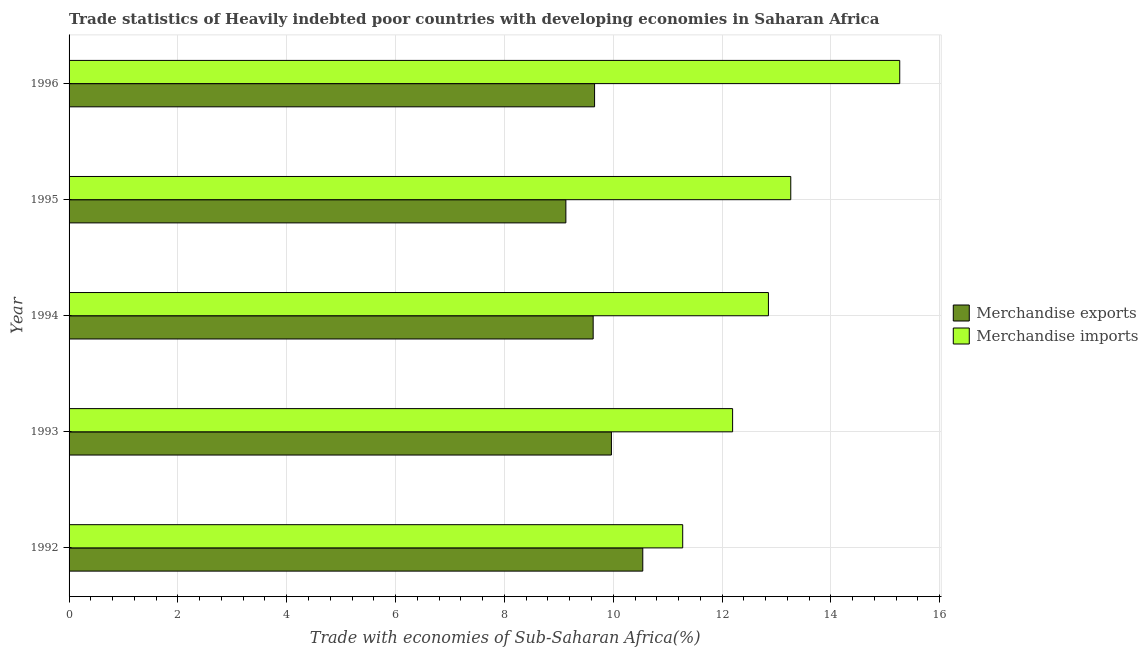How many different coloured bars are there?
Provide a short and direct response. 2. How many groups of bars are there?
Offer a very short reply. 5. Are the number of bars on each tick of the Y-axis equal?
Provide a short and direct response. Yes. How many bars are there on the 1st tick from the top?
Keep it short and to the point. 2. How many bars are there on the 1st tick from the bottom?
Offer a terse response. 2. What is the label of the 3rd group of bars from the top?
Your answer should be compact. 1994. In how many cases, is the number of bars for a given year not equal to the number of legend labels?
Provide a succinct answer. 0. What is the merchandise exports in 1993?
Make the answer very short. 9.97. Across all years, what is the maximum merchandise exports?
Offer a terse response. 10.54. Across all years, what is the minimum merchandise imports?
Keep it short and to the point. 11.28. In which year was the merchandise exports maximum?
Your response must be concise. 1992. What is the total merchandise exports in the graph?
Make the answer very short. 48.93. What is the difference between the merchandise exports in 1993 and that in 1995?
Provide a succinct answer. 0.84. What is the difference between the merchandise exports in 1994 and the merchandise imports in 1993?
Provide a succinct answer. -2.56. What is the average merchandise imports per year?
Make the answer very short. 12.97. In the year 1993, what is the difference between the merchandise imports and merchandise exports?
Give a very brief answer. 2.23. What is the ratio of the merchandise exports in 1994 to that in 1996?
Provide a short and direct response. 1. What is the difference between the highest and the second highest merchandise exports?
Your answer should be compact. 0.58. What is the difference between the highest and the lowest merchandise imports?
Provide a short and direct response. 3.99. Is the sum of the merchandise imports in 1992 and 1993 greater than the maximum merchandise exports across all years?
Make the answer very short. Yes. What does the 1st bar from the bottom in 1993 represents?
Keep it short and to the point. Merchandise exports. How many years are there in the graph?
Offer a terse response. 5. What is the difference between two consecutive major ticks on the X-axis?
Provide a short and direct response. 2. Does the graph contain grids?
Ensure brevity in your answer.  Yes. What is the title of the graph?
Offer a terse response. Trade statistics of Heavily indebted poor countries with developing economies in Saharan Africa. What is the label or title of the X-axis?
Your answer should be compact. Trade with economies of Sub-Saharan Africa(%). What is the label or title of the Y-axis?
Give a very brief answer. Year. What is the Trade with economies of Sub-Saharan Africa(%) of Merchandise exports in 1992?
Keep it short and to the point. 10.54. What is the Trade with economies of Sub-Saharan Africa(%) of Merchandise imports in 1992?
Keep it short and to the point. 11.28. What is the Trade with economies of Sub-Saharan Africa(%) in Merchandise exports in 1993?
Ensure brevity in your answer.  9.97. What is the Trade with economies of Sub-Saharan Africa(%) in Merchandise imports in 1993?
Keep it short and to the point. 12.19. What is the Trade with economies of Sub-Saharan Africa(%) in Merchandise exports in 1994?
Provide a short and direct response. 9.63. What is the Trade with economies of Sub-Saharan Africa(%) in Merchandise imports in 1994?
Your answer should be compact. 12.85. What is the Trade with economies of Sub-Saharan Africa(%) in Merchandise exports in 1995?
Your answer should be very brief. 9.13. What is the Trade with economies of Sub-Saharan Africa(%) of Merchandise imports in 1995?
Ensure brevity in your answer.  13.26. What is the Trade with economies of Sub-Saharan Africa(%) of Merchandise exports in 1996?
Ensure brevity in your answer.  9.66. What is the Trade with economies of Sub-Saharan Africa(%) in Merchandise imports in 1996?
Your answer should be very brief. 15.27. Across all years, what is the maximum Trade with economies of Sub-Saharan Africa(%) of Merchandise exports?
Offer a terse response. 10.54. Across all years, what is the maximum Trade with economies of Sub-Saharan Africa(%) of Merchandise imports?
Your response must be concise. 15.27. Across all years, what is the minimum Trade with economies of Sub-Saharan Africa(%) in Merchandise exports?
Provide a succinct answer. 9.13. Across all years, what is the minimum Trade with economies of Sub-Saharan Africa(%) of Merchandise imports?
Keep it short and to the point. 11.28. What is the total Trade with economies of Sub-Saharan Africa(%) in Merchandise exports in the graph?
Offer a very short reply. 48.93. What is the total Trade with economies of Sub-Saharan Africa(%) of Merchandise imports in the graph?
Give a very brief answer. 64.85. What is the difference between the Trade with economies of Sub-Saharan Africa(%) in Merchandise exports in 1992 and that in 1993?
Offer a very short reply. 0.58. What is the difference between the Trade with economies of Sub-Saharan Africa(%) in Merchandise imports in 1992 and that in 1993?
Offer a terse response. -0.92. What is the difference between the Trade with economies of Sub-Saharan Africa(%) of Merchandise exports in 1992 and that in 1994?
Offer a very short reply. 0.91. What is the difference between the Trade with economies of Sub-Saharan Africa(%) of Merchandise imports in 1992 and that in 1994?
Your answer should be compact. -1.58. What is the difference between the Trade with economies of Sub-Saharan Africa(%) in Merchandise exports in 1992 and that in 1995?
Make the answer very short. 1.41. What is the difference between the Trade with economies of Sub-Saharan Africa(%) in Merchandise imports in 1992 and that in 1995?
Your answer should be very brief. -1.99. What is the difference between the Trade with economies of Sub-Saharan Africa(%) of Merchandise exports in 1992 and that in 1996?
Your answer should be compact. 0.89. What is the difference between the Trade with economies of Sub-Saharan Africa(%) in Merchandise imports in 1992 and that in 1996?
Provide a short and direct response. -3.99. What is the difference between the Trade with economies of Sub-Saharan Africa(%) of Merchandise exports in 1993 and that in 1994?
Make the answer very short. 0.34. What is the difference between the Trade with economies of Sub-Saharan Africa(%) of Merchandise imports in 1993 and that in 1994?
Provide a succinct answer. -0.66. What is the difference between the Trade with economies of Sub-Saharan Africa(%) in Merchandise exports in 1993 and that in 1995?
Make the answer very short. 0.84. What is the difference between the Trade with economies of Sub-Saharan Africa(%) in Merchandise imports in 1993 and that in 1995?
Provide a short and direct response. -1.07. What is the difference between the Trade with economies of Sub-Saharan Africa(%) in Merchandise exports in 1993 and that in 1996?
Provide a succinct answer. 0.31. What is the difference between the Trade with economies of Sub-Saharan Africa(%) in Merchandise imports in 1993 and that in 1996?
Keep it short and to the point. -3.07. What is the difference between the Trade with economies of Sub-Saharan Africa(%) of Merchandise exports in 1994 and that in 1995?
Provide a succinct answer. 0.5. What is the difference between the Trade with economies of Sub-Saharan Africa(%) in Merchandise imports in 1994 and that in 1995?
Offer a terse response. -0.41. What is the difference between the Trade with economies of Sub-Saharan Africa(%) in Merchandise exports in 1994 and that in 1996?
Offer a terse response. -0.03. What is the difference between the Trade with economies of Sub-Saharan Africa(%) in Merchandise imports in 1994 and that in 1996?
Your answer should be very brief. -2.41. What is the difference between the Trade with economies of Sub-Saharan Africa(%) in Merchandise exports in 1995 and that in 1996?
Give a very brief answer. -0.53. What is the difference between the Trade with economies of Sub-Saharan Africa(%) of Merchandise imports in 1995 and that in 1996?
Your response must be concise. -2. What is the difference between the Trade with economies of Sub-Saharan Africa(%) in Merchandise exports in 1992 and the Trade with economies of Sub-Saharan Africa(%) in Merchandise imports in 1993?
Offer a very short reply. -1.65. What is the difference between the Trade with economies of Sub-Saharan Africa(%) in Merchandise exports in 1992 and the Trade with economies of Sub-Saharan Africa(%) in Merchandise imports in 1994?
Keep it short and to the point. -2.31. What is the difference between the Trade with economies of Sub-Saharan Africa(%) in Merchandise exports in 1992 and the Trade with economies of Sub-Saharan Africa(%) in Merchandise imports in 1995?
Your answer should be compact. -2.72. What is the difference between the Trade with economies of Sub-Saharan Africa(%) in Merchandise exports in 1992 and the Trade with economies of Sub-Saharan Africa(%) in Merchandise imports in 1996?
Your answer should be very brief. -4.72. What is the difference between the Trade with economies of Sub-Saharan Africa(%) in Merchandise exports in 1993 and the Trade with economies of Sub-Saharan Africa(%) in Merchandise imports in 1994?
Make the answer very short. -2.89. What is the difference between the Trade with economies of Sub-Saharan Africa(%) in Merchandise exports in 1993 and the Trade with economies of Sub-Saharan Africa(%) in Merchandise imports in 1995?
Your answer should be compact. -3.3. What is the difference between the Trade with economies of Sub-Saharan Africa(%) of Merchandise exports in 1993 and the Trade with economies of Sub-Saharan Africa(%) of Merchandise imports in 1996?
Your answer should be very brief. -5.3. What is the difference between the Trade with economies of Sub-Saharan Africa(%) of Merchandise exports in 1994 and the Trade with economies of Sub-Saharan Africa(%) of Merchandise imports in 1995?
Offer a very short reply. -3.63. What is the difference between the Trade with economies of Sub-Saharan Africa(%) in Merchandise exports in 1994 and the Trade with economies of Sub-Saharan Africa(%) in Merchandise imports in 1996?
Give a very brief answer. -5.63. What is the difference between the Trade with economies of Sub-Saharan Africa(%) of Merchandise exports in 1995 and the Trade with economies of Sub-Saharan Africa(%) of Merchandise imports in 1996?
Give a very brief answer. -6.14. What is the average Trade with economies of Sub-Saharan Africa(%) of Merchandise exports per year?
Offer a terse response. 9.79. What is the average Trade with economies of Sub-Saharan Africa(%) in Merchandise imports per year?
Your answer should be compact. 12.97. In the year 1992, what is the difference between the Trade with economies of Sub-Saharan Africa(%) in Merchandise exports and Trade with economies of Sub-Saharan Africa(%) in Merchandise imports?
Your response must be concise. -0.73. In the year 1993, what is the difference between the Trade with economies of Sub-Saharan Africa(%) in Merchandise exports and Trade with economies of Sub-Saharan Africa(%) in Merchandise imports?
Your answer should be very brief. -2.23. In the year 1994, what is the difference between the Trade with economies of Sub-Saharan Africa(%) of Merchandise exports and Trade with economies of Sub-Saharan Africa(%) of Merchandise imports?
Provide a succinct answer. -3.22. In the year 1995, what is the difference between the Trade with economies of Sub-Saharan Africa(%) of Merchandise exports and Trade with economies of Sub-Saharan Africa(%) of Merchandise imports?
Keep it short and to the point. -4.13. In the year 1996, what is the difference between the Trade with economies of Sub-Saharan Africa(%) of Merchandise exports and Trade with economies of Sub-Saharan Africa(%) of Merchandise imports?
Your response must be concise. -5.61. What is the ratio of the Trade with economies of Sub-Saharan Africa(%) in Merchandise exports in 1992 to that in 1993?
Give a very brief answer. 1.06. What is the ratio of the Trade with economies of Sub-Saharan Africa(%) of Merchandise imports in 1992 to that in 1993?
Offer a terse response. 0.92. What is the ratio of the Trade with economies of Sub-Saharan Africa(%) of Merchandise exports in 1992 to that in 1994?
Give a very brief answer. 1.09. What is the ratio of the Trade with economies of Sub-Saharan Africa(%) of Merchandise imports in 1992 to that in 1994?
Provide a succinct answer. 0.88. What is the ratio of the Trade with economies of Sub-Saharan Africa(%) in Merchandise exports in 1992 to that in 1995?
Provide a succinct answer. 1.15. What is the ratio of the Trade with economies of Sub-Saharan Africa(%) in Merchandise imports in 1992 to that in 1995?
Offer a terse response. 0.85. What is the ratio of the Trade with economies of Sub-Saharan Africa(%) of Merchandise exports in 1992 to that in 1996?
Offer a terse response. 1.09. What is the ratio of the Trade with economies of Sub-Saharan Africa(%) of Merchandise imports in 1992 to that in 1996?
Your answer should be very brief. 0.74. What is the ratio of the Trade with economies of Sub-Saharan Africa(%) of Merchandise exports in 1993 to that in 1994?
Give a very brief answer. 1.03. What is the ratio of the Trade with economies of Sub-Saharan Africa(%) of Merchandise imports in 1993 to that in 1994?
Keep it short and to the point. 0.95. What is the ratio of the Trade with economies of Sub-Saharan Africa(%) in Merchandise exports in 1993 to that in 1995?
Offer a very short reply. 1.09. What is the ratio of the Trade with economies of Sub-Saharan Africa(%) of Merchandise imports in 1993 to that in 1995?
Provide a short and direct response. 0.92. What is the ratio of the Trade with economies of Sub-Saharan Africa(%) in Merchandise exports in 1993 to that in 1996?
Make the answer very short. 1.03. What is the ratio of the Trade with economies of Sub-Saharan Africa(%) of Merchandise imports in 1993 to that in 1996?
Give a very brief answer. 0.8. What is the ratio of the Trade with economies of Sub-Saharan Africa(%) of Merchandise exports in 1994 to that in 1995?
Provide a succinct answer. 1.05. What is the ratio of the Trade with economies of Sub-Saharan Africa(%) of Merchandise imports in 1994 to that in 1995?
Make the answer very short. 0.97. What is the ratio of the Trade with economies of Sub-Saharan Africa(%) in Merchandise exports in 1994 to that in 1996?
Offer a very short reply. 1. What is the ratio of the Trade with economies of Sub-Saharan Africa(%) in Merchandise imports in 1994 to that in 1996?
Give a very brief answer. 0.84. What is the ratio of the Trade with economies of Sub-Saharan Africa(%) in Merchandise exports in 1995 to that in 1996?
Make the answer very short. 0.95. What is the ratio of the Trade with economies of Sub-Saharan Africa(%) of Merchandise imports in 1995 to that in 1996?
Your answer should be very brief. 0.87. What is the difference between the highest and the second highest Trade with economies of Sub-Saharan Africa(%) of Merchandise exports?
Make the answer very short. 0.58. What is the difference between the highest and the second highest Trade with economies of Sub-Saharan Africa(%) in Merchandise imports?
Your answer should be compact. 2. What is the difference between the highest and the lowest Trade with economies of Sub-Saharan Africa(%) in Merchandise exports?
Your response must be concise. 1.41. What is the difference between the highest and the lowest Trade with economies of Sub-Saharan Africa(%) in Merchandise imports?
Ensure brevity in your answer.  3.99. 